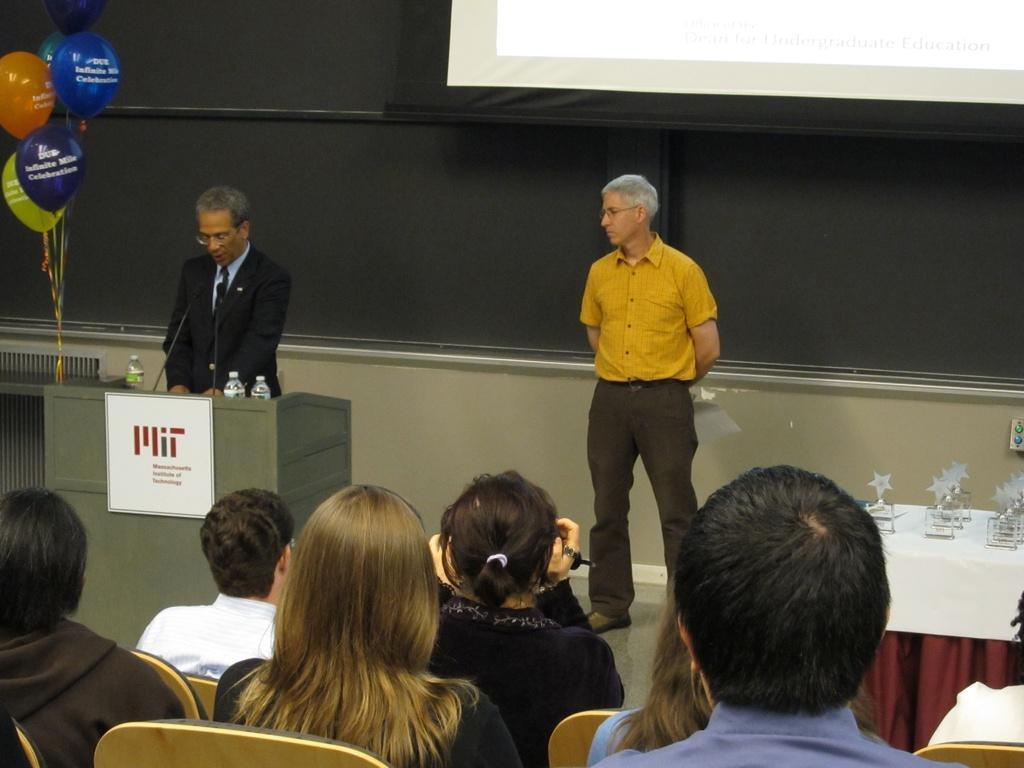Describe this image in one or two sentences. In the background we can see the projector screen and the wall. In this picture we can see the men standing. We can see a podium and on a podium we can see the microphones and water bottles. We can see a board and balloons. On the right side of the picture we can see the awards placed on the table. At the bottom portion of the picture we can see the people sitting on the chairs. 